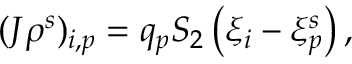Convert formula to latex. <formula><loc_0><loc_0><loc_500><loc_500>\begin{array} { r } { ( J \rho ^ { s } ) _ { i , p } = q _ { p } S _ { 2 } \left ( { \xi } _ { i } - { \xi } _ { p } ^ { s } \right ) , } \end{array}</formula> 